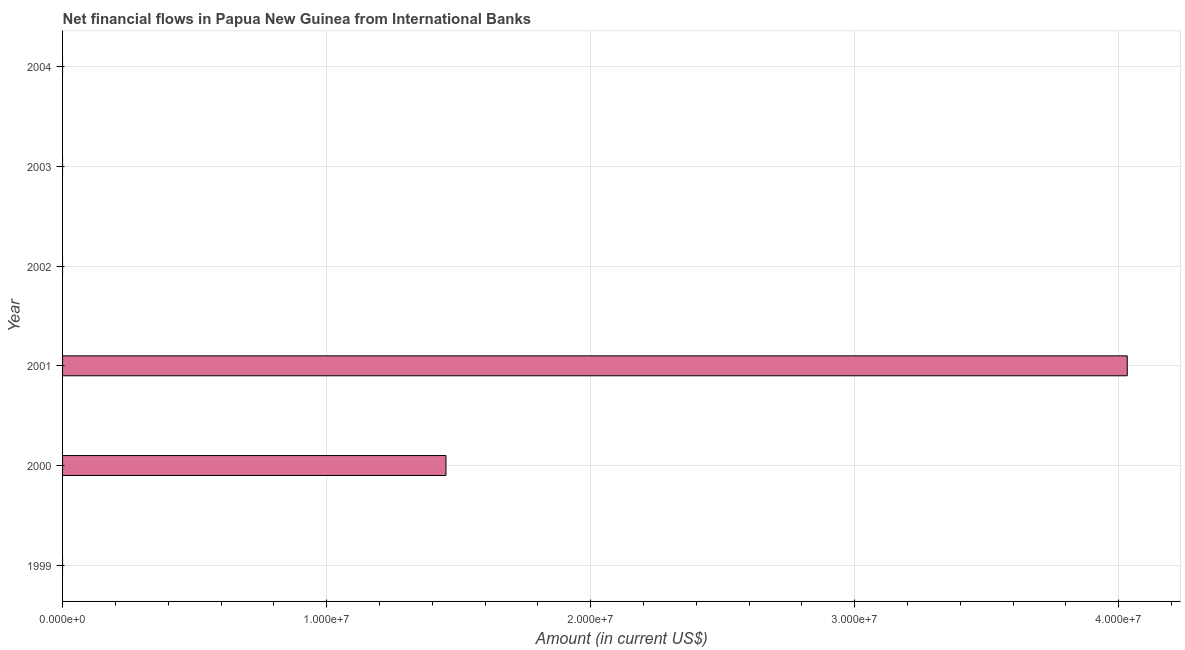Does the graph contain any zero values?
Keep it short and to the point. Yes. What is the title of the graph?
Your response must be concise. Net financial flows in Papua New Guinea from International Banks. What is the label or title of the X-axis?
Ensure brevity in your answer.  Amount (in current US$). What is the label or title of the Y-axis?
Ensure brevity in your answer.  Year. What is the net financial flows from ibrd in 2001?
Offer a terse response. 4.03e+07. Across all years, what is the maximum net financial flows from ibrd?
Ensure brevity in your answer.  4.03e+07. Across all years, what is the minimum net financial flows from ibrd?
Make the answer very short. 0. What is the sum of the net financial flows from ibrd?
Provide a short and direct response. 5.48e+07. What is the difference between the net financial flows from ibrd in 2000 and 2001?
Provide a succinct answer. -2.58e+07. What is the average net financial flows from ibrd per year?
Your response must be concise. 9.14e+06. What is the median net financial flows from ibrd?
Make the answer very short. 0. In how many years, is the net financial flows from ibrd greater than 10000000 US$?
Provide a short and direct response. 2. Is the sum of the net financial flows from ibrd in 2000 and 2001 greater than the maximum net financial flows from ibrd across all years?
Provide a succinct answer. Yes. What is the difference between the highest and the lowest net financial flows from ibrd?
Make the answer very short. 4.03e+07. How many bars are there?
Ensure brevity in your answer.  2. How many years are there in the graph?
Keep it short and to the point. 6. Are the values on the major ticks of X-axis written in scientific E-notation?
Your response must be concise. Yes. What is the Amount (in current US$) in 1999?
Ensure brevity in your answer.  0. What is the Amount (in current US$) in 2000?
Give a very brief answer. 1.45e+07. What is the Amount (in current US$) of 2001?
Your response must be concise. 4.03e+07. What is the difference between the Amount (in current US$) in 2000 and 2001?
Ensure brevity in your answer.  -2.58e+07. What is the ratio of the Amount (in current US$) in 2000 to that in 2001?
Give a very brief answer. 0.36. 